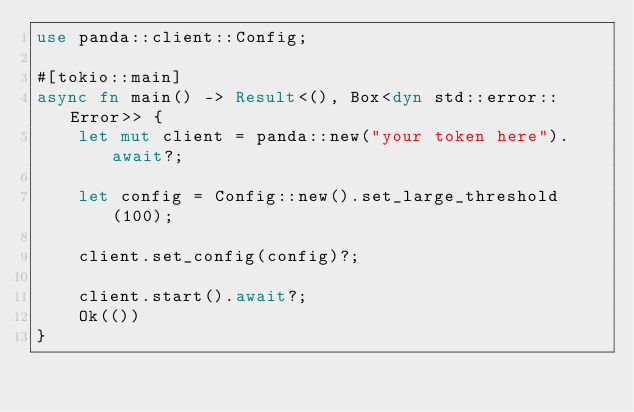Convert code to text. <code><loc_0><loc_0><loc_500><loc_500><_Rust_>use panda::client::Config;

#[tokio::main]
async fn main() -> Result<(), Box<dyn std::error::Error>> {
    let mut client = panda::new("your token here").await?;

    let config = Config::new().set_large_threshold(100);

    client.set_config(config)?;

    client.start().await?;
    Ok(())
}
</code> 